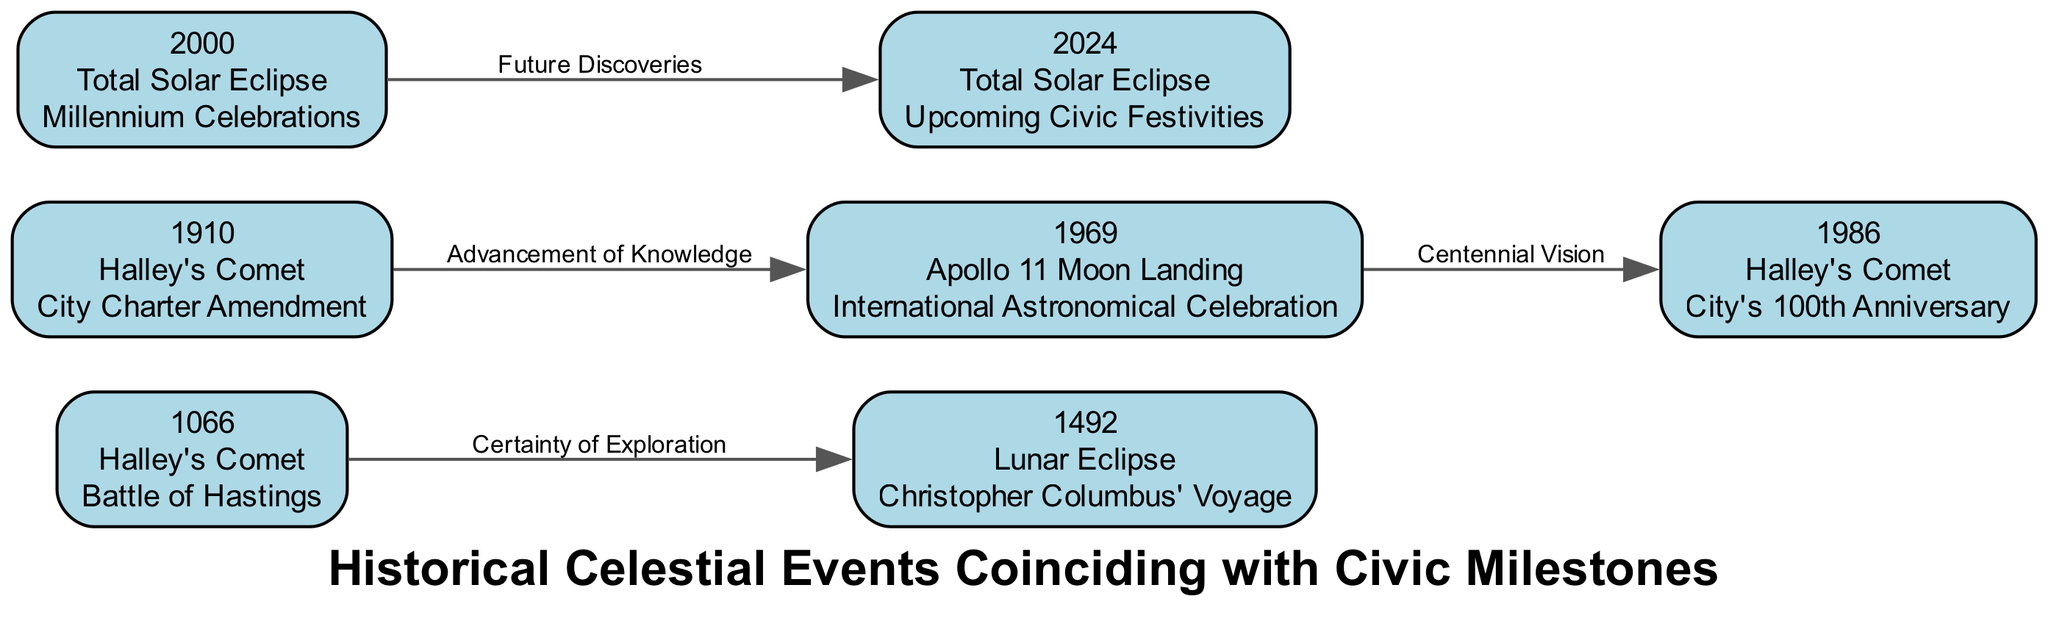What celestial event occurred in 1066? The diagram specifies that the celestial event in 1066 was Halley's Comet, as indicated in the node labeled "1066."
Answer: Halley's Comet What civic milestone coincided with the total solar eclipse in 2000? Referring to the node labeled "2000," the diagram notes that the total solar eclipse coincided with the Millennium Celebrations.
Answer: Millennium Celebrations How many nodes are present in the diagram? By counting the nodes listed, we find that there are 7 nodes in total, representing various years, events, and milestones.
Answer: 7 What is the relationship between the Apollo 11 Moon Landing and the city's 100th Anniversary? The diagram shows an edge connecting the Apollo 11 Moon Landing (1969) to the city's 100th Anniversary (1986), labeled "Centennial Vision," indicating a thematic connection between these events.
Answer: Centennial Vision What is the upcoming civic milestone associated with the total solar eclipse in 2024? The node labeled "2024" indicates that the upcoming civic milestone associated with the total solar eclipse is "Upcoming Civic Festivities."
Answer: Upcoming Civic Festivities What event is linked to Halley's Comet in 1986? According to the node for 1986, Halley's Comet is linked to the city's 100th Anniversary, showing a historical connection between the two.
Answer: City's 100th Anniversary Which two celestial events are associated with exploration? The diagram indicates that both the Halley's Comet in 1066 and the Lunar Eclipse in 1492 are linked to exploration. Halley's Comet is described as "Certainty of Exploration" and the Lunar Eclipse as a significant event during Columbus' voyage.
Answer: Halley's Comet and Lunar Eclipse What are the future implications of the total solar eclipse in 2000? The edge from the year 2000 to 2024 indicates "Future Discoveries," suggesting that this solar eclipse serves as a precursor to further exploration and civic engagement connected with the upcoming eclipse.
Answer: Future Discoveries 